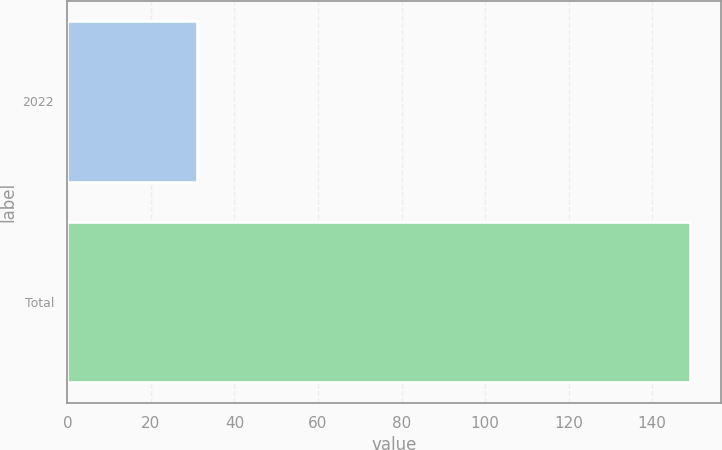Convert chart. <chart><loc_0><loc_0><loc_500><loc_500><bar_chart><fcel>2022<fcel>Total<nl><fcel>31<fcel>149<nl></chart> 